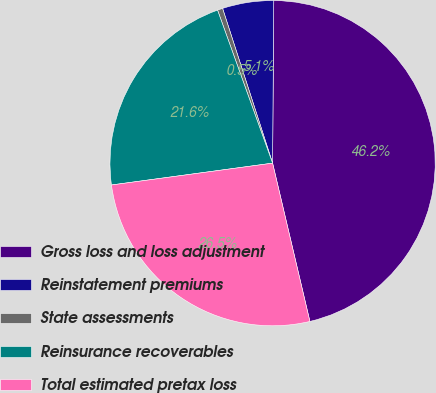Convert chart. <chart><loc_0><loc_0><loc_500><loc_500><pie_chart><fcel>Gross loss and loss adjustment<fcel>Reinstatement premiums<fcel>State assessments<fcel>Reinsurance recoverables<fcel>Total estimated pretax loss<nl><fcel>46.2%<fcel>5.09%<fcel>0.52%<fcel>21.65%<fcel>26.54%<nl></chart> 